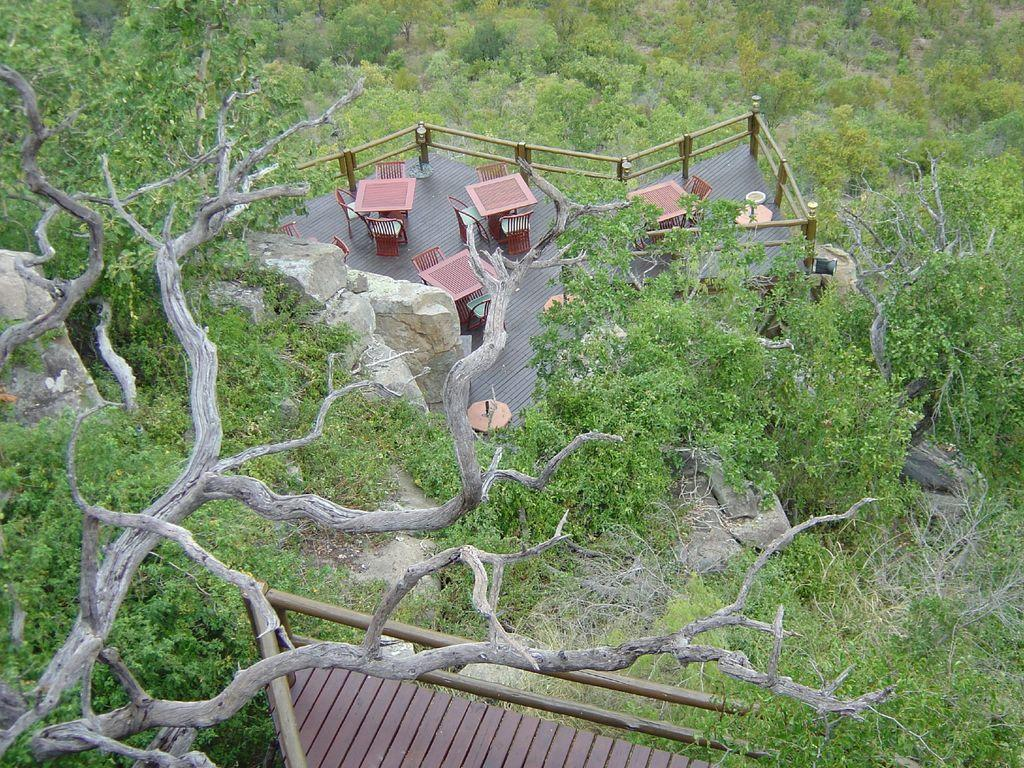What type of natural elements can be seen in the image? There are many trees in the image. What type of geological features are present at the bottom of the image? There are rocks at the bottom of the image. What type of furniture is visible in the image? Tables and chairs are visible in the image. What type of structure is present in the image? There is a railing in the image. What type of setting does the image depict? The image appears to depict a restaurant setting. How does the image show the increase in popcorn consumption over time? The image does not show any popcorn or any indication of popcorn consumption. Can you tell me how many people are sleeping in the image? There are no people sleeping in the image; it depicts a restaurant setting with tables, chairs, and trees. 